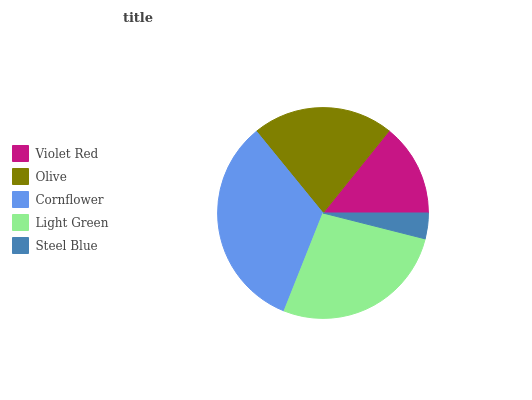Is Steel Blue the minimum?
Answer yes or no. Yes. Is Cornflower the maximum?
Answer yes or no. Yes. Is Olive the minimum?
Answer yes or no. No. Is Olive the maximum?
Answer yes or no. No. Is Olive greater than Violet Red?
Answer yes or no. Yes. Is Violet Red less than Olive?
Answer yes or no. Yes. Is Violet Red greater than Olive?
Answer yes or no. No. Is Olive less than Violet Red?
Answer yes or no. No. Is Olive the high median?
Answer yes or no. Yes. Is Olive the low median?
Answer yes or no. Yes. Is Steel Blue the high median?
Answer yes or no. No. Is Violet Red the low median?
Answer yes or no. No. 